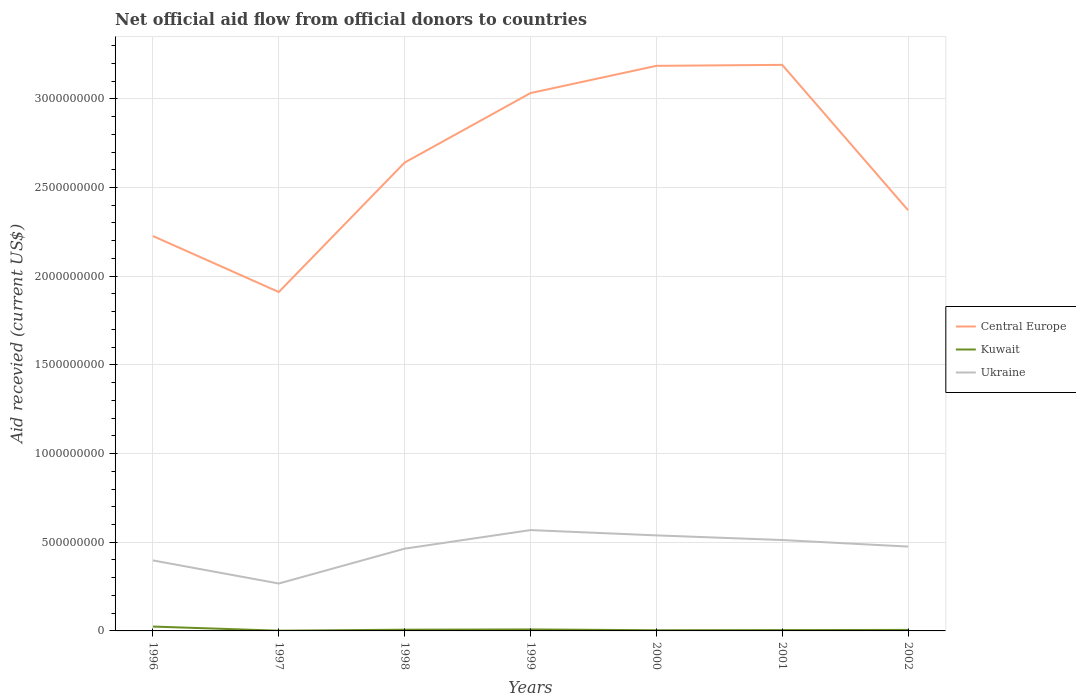How many different coloured lines are there?
Offer a terse response. 3. Does the line corresponding to Ukraine intersect with the line corresponding to Central Europe?
Keep it short and to the point. No. Is the number of lines equal to the number of legend labels?
Give a very brief answer. Yes. Across all years, what is the maximum total aid received in Kuwait?
Give a very brief answer. 1.28e+06. In which year was the total aid received in Central Europe maximum?
Your answer should be compact. 1997. What is the total total aid received in Kuwait in the graph?
Your answer should be compact. 1.63e+07. What is the difference between the highest and the second highest total aid received in Central Europe?
Give a very brief answer. 1.28e+09. What is the difference between the highest and the lowest total aid received in Ukraine?
Offer a very short reply. 5. Is the total aid received in Central Europe strictly greater than the total aid received in Ukraine over the years?
Offer a very short reply. No. How many lines are there?
Offer a terse response. 3. What is the difference between two consecutive major ticks on the Y-axis?
Offer a terse response. 5.00e+08. Are the values on the major ticks of Y-axis written in scientific E-notation?
Make the answer very short. No. Does the graph contain any zero values?
Ensure brevity in your answer.  No. Where does the legend appear in the graph?
Make the answer very short. Center right. How many legend labels are there?
Make the answer very short. 3. What is the title of the graph?
Your response must be concise. Net official aid flow from official donors to countries. Does "Montenegro" appear as one of the legend labels in the graph?
Your answer should be compact. No. What is the label or title of the Y-axis?
Keep it short and to the point. Aid recevied (current US$). What is the Aid recevied (current US$) in Central Europe in 1996?
Offer a terse response. 2.23e+09. What is the Aid recevied (current US$) of Kuwait in 1996?
Offer a very short reply. 2.46e+07. What is the Aid recevied (current US$) of Ukraine in 1996?
Offer a terse response. 3.98e+08. What is the Aid recevied (current US$) of Central Europe in 1997?
Provide a short and direct response. 1.91e+09. What is the Aid recevied (current US$) of Kuwait in 1997?
Make the answer very short. 1.28e+06. What is the Aid recevied (current US$) of Ukraine in 1997?
Keep it short and to the point. 2.67e+08. What is the Aid recevied (current US$) of Central Europe in 1998?
Keep it short and to the point. 2.64e+09. What is the Aid recevied (current US$) of Kuwait in 1998?
Keep it short and to the point. 6.99e+06. What is the Aid recevied (current US$) of Ukraine in 1998?
Make the answer very short. 4.64e+08. What is the Aid recevied (current US$) of Central Europe in 1999?
Give a very brief answer. 3.03e+09. What is the Aid recevied (current US$) of Kuwait in 1999?
Offer a terse response. 8.33e+06. What is the Aid recevied (current US$) of Ukraine in 1999?
Your response must be concise. 5.69e+08. What is the Aid recevied (current US$) of Central Europe in 2000?
Your response must be concise. 3.19e+09. What is the Aid recevied (current US$) in Kuwait in 2000?
Your answer should be compact. 3.89e+06. What is the Aid recevied (current US$) of Ukraine in 2000?
Your answer should be very brief. 5.39e+08. What is the Aid recevied (current US$) of Central Europe in 2001?
Your answer should be very brief. 3.19e+09. What is the Aid recevied (current US$) in Kuwait in 2001?
Provide a succinct answer. 4.69e+06. What is the Aid recevied (current US$) in Ukraine in 2001?
Make the answer very short. 5.12e+08. What is the Aid recevied (current US$) of Central Europe in 2002?
Provide a short and direct response. 2.37e+09. What is the Aid recevied (current US$) of Kuwait in 2002?
Provide a short and direct response. 5.71e+06. What is the Aid recevied (current US$) in Ukraine in 2002?
Provide a succinct answer. 4.76e+08. Across all years, what is the maximum Aid recevied (current US$) in Central Europe?
Keep it short and to the point. 3.19e+09. Across all years, what is the maximum Aid recevied (current US$) in Kuwait?
Your response must be concise. 2.46e+07. Across all years, what is the maximum Aid recevied (current US$) of Ukraine?
Provide a short and direct response. 5.69e+08. Across all years, what is the minimum Aid recevied (current US$) of Central Europe?
Make the answer very short. 1.91e+09. Across all years, what is the minimum Aid recevied (current US$) in Kuwait?
Provide a short and direct response. 1.28e+06. Across all years, what is the minimum Aid recevied (current US$) in Ukraine?
Ensure brevity in your answer.  2.67e+08. What is the total Aid recevied (current US$) of Central Europe in the graph?
Your response must be concise. 1.86e+1. What is the total Aid recevied (current US$) in Kuwait in the graph?
Provide a succinct answer. 5.55e+07. What is the total Aid recevied (current US$) of Ukraine in the graph?
Your answer should be compact. 3.22e+09. What is the difference between the Aid recevied (current US$) of Central Europe in 1996 and that in 1997?
Your answer should be very brief. 3.16e+08. What is the difference between the Aid recevied (current US$) of Kuwait in 1996 and that in 1997?
Make the answer very short. 2.33e+07. What is the difference between the Aid recevied (current US$) in Ukraine in 1996 and that in 1997?
Your response must be concise. 1.30e+08. What is the difference between the Aid recevied (current US$) in Central Europe in 1996 and that in 1998?
Offer a terse response. -4.14e+08. What is the difference between the Aid recevied (current US$) of Kuwait in 1996 and that in 1998?
Ensure brevity in your answer.  1.76e+07. What is the difference between the Aid recevied (current US$) in Ukraine in 1996 and that in 1998?
Make the answer very short. -6.61e+07. What is the difference between the Aid recevied (current US$) in Central Europe in 1996 and that in 1999?
Your response must be concise. -8.06e+08. What is the difference between the Aid recevied (current US$) of Kuwait in 1996 and that in 1999?
Your answer should be very brief. 1.63e+07. What is the difference between the Aid recevied (current US$) of Ukraine in 1996 and that in 1999?
Your answer should be compact. -1.71e+08. What is the difference between the Aid recevied (current US$) in Central Europe in 1996 and that in 2000?
Ensure brevity in your answer.  -9.60e+08. What is the difference between the Aid recevied (current US$) of Kuwait in 1996 and that in 2000?
Give a very brief answer. 2.07e+07. What is the difference between the Aid recevied (current US$) in Ukraine in 1996 and that in 2000?
Give a very brief answer. -1.41e+08. What is the difference between the Aid recevied (current US$) of Central Europe in 1996 and that in 2001?
Your answer should be compact. -9.65e+08. What is the difference between the Aid recevied (current US$) of Kuwait in 1996 and that in 2001?
Provide a short and direct response. 1.99e+07. What is the difference between the Aid recevied (current US$) of Ukraine in 1996 and that in 2001?
Provide a succinct answer. -1.15e+08. What is the difference between the Aid recevied (current US$) of Central Europe in 1996 and that in 2002?
Provide a succinct answer. -1.46e+08. What is the difference between the Aid recevied (current US$) in Kuwait in 1996 and that in 2002?
Give a very brief answer. 1.89e+07. What is the difference between the Aid recevied (current US$) in Ukraine in 1996 and that in 2002?
Offer a terse response. -7.79e+07. What is the difference between the Aid recevied (current US$) in Central Europe in 1997 and that in 1998?
Your response must be concise. -7.30e+08. What is the difference between the Aid recevied (current US$) in Kuwait in 1997 and that in 1998?
Provide a short and direct response. -5.71e+06. What is the difference between the Aid recevied (current US$) of Ukraine in 1997 and that in 1998?
Your response must be concise. -1.96e+08. What is the difference between the Aid recevied (current US$) in Central Europe in 1997 and that in 1999?
Offer a very short reply. -1.12e+09. What is the difference between the Aid recevied (current US$) of Kuwait in 1997 and that in 1999?
Provide a short and direct response. -7.05e+06. What is the difference between the Aid recevied (current US$) in Ukraine in 1997 and that in 1999?
Give a very brief answer. -3.01e+08. What is the difference between the Aid recevied (current US$) of Central Europe in 1997 and that in 2000?
Make the answer very short. -1.28e+09. What is the difference between the Aid recevied (current US$) in Kuwait in 1997 and that in 2000?
Ensure brevity in your answer.  -2.61e+06. What is the difference between the Aid recevied (current US$) of Ukraine in 1997 and that in 2000?
Keep it short and to the point. -2.71e+08. What is the difference between the Aid recevied (current US$) of Central Europe in 1997 and that in 2001?
Keep it short and to the point. -1.28e+09. What is the difference between the Aid recevied (current US$) of Kuwait in 1997 and that in 2001?
Your answer should be very brief. -3.41e+06. What is the difference between the Aid recevied (current US$) in Ukraine in 1997 and that in 2001?
Your answer should be very brief. -2.45e+08. What is the difference between the Aid recevied (current US$) in Central Europe in 1997 and that in 2002?
Ensure brevity in your answer.  -4.61e+08. What is the difference between the Aid recevied (current US$) in Kuwait in 1997 and that in 2002?
Provide a short and direct response. -4.43e+06. What is the difference between the Aid recevied (current US$) of Ukraine in 1997 and that in 2002?
Make the answer very short. -2.08e+08. What is the difference between the Aid recevied (current US$) of Central Europe in 1998 and that in 1999?
Provide a succinct answer. -3.92e+08. What is the difference between the Aid recevied (current US$) in Kuwait in 1998 and that in 1999?
Your answer should be compact. -1.34e+06. What is the difference between the Aid recevied (current US$) in Ukraine in 1998 and that in 1999?
Your response must be concise. -1.05e+08. What is the difference between the Aid recevied (current US$) in Central Europe in 1998 and that in 2000?
Give a very brief answer. -5.45e+08. What is the difference between the Aid recevied (current US$) in Kuwait in 1998 and that in 2000?
Keep it short and to the point. 3.10e+06. What is the difference between the Aid recevied (current US$) of Ukraine in 1998 and that in 2000?
Provide a short and direct response. -7.50e+07. What is the difference between the Aid recevied (current US$) of Central Europe in 1998 and that in 2001?
Ensure brevity in your answer.  -5.51e+08. What is the difference between the Aid recevied (current US$) in Kuwait in 1998 and that in 2001?
Offer a very short reply. 2.30e+06. What is the difference between the Aid recevied (current US$) of Ukraine in 1998 and that in 2001?
Offer a very short reply. -4.87e+07. What is the difference between the Aid recevied (current US$) of Central Europe in 1998 and that in 2002?
Your answer should be compact. 2.68e+08. What is the difference between the Aid recevied (current US$) in Kuwait in 1998 and that in 2002?
Provide a short and direct response. 1.28e+06. What is the difference between the Aid recevied (current US$) of Ukraine in 1998 and that in 2002?
Keep it short and to the point. -1.18e+07. What is the difference between the Aid recevied (current US$) in Central Europe in 1999 and that in 2000?
Provide a succinct answer. -1.54e+08. What is the difference between the Aid recevied (current US$) of Kuwait in 1999 and that in 2000?
Offer a terse response. 4.44e+06. What is the difference between the Aid recevied (current US$) in Ukraine in 1999 and that in 2000?
Make the answer very short. 2.98e+07. What is the difference between the Aid recevied (current US$) in Central Europe in 1999 and that in 2001?
Offer a terse response. -1.59e+08. What is the difference between the Aid recevied (current US$) in Kuwait in 1999 and that in 2001?
Your response must be concise. 3.64e+06. What is the difference between the Aid recevied (current US$) of Ukraine in 1999 and that in 2001?
Give a very brief answer. 5.61e+07. What is the difference between the Aid recevied (current US$) in Central Europe in 1999 and that in 2002?
Offer a terse response. 6.60e+08. What is the difference between the Aid recevied (current US$) of Kuwait in 1999 and that in 2002?
Your response must be concise. 2.62e+06. What is the difference between the Aid recevied (current US$) of Ukraine in 1999 and that in 2002?
Offer a terse response. 9.30e+07. What is the difference between the Aid recevied (current US$) in Central Europe in 2000 and that in 2001?
Your answer should be very brief. -5.47e+06. What is the difference between the Aid recevied (current US$) of Kuwait in 2000 and that in 2001?
Offer a terse response. -8.00e+05. What is the difference between the Aid recevied (current US$) of Ukraine in 2000 and that in 2001?
Ensure brevity in your answer.  2.62e+07. What is the difference between the Aid recevied (current US$) of Central Europe in 2000 and that in 2002?
Provide a succinct answer. 8.14e+08. What is the difference between the Aid recevied (current US$) of Kuwait in 2000 and that in 2002?
Provide a short and direct response. -1.82e+06. What is the difference between the Aid recevied (current US$) in Ukraine in 2000 and that in 2002?
Offer a terse response. 6.32e+07. What is the difference between the Aid recevied (current US$) in Central Europe in 2001 and that in 2002?
Keep it short and to the point. 8.19e+08. What is the difference between the Aid recevied (current US$) in Kuwait in 2001 and that in 2002?
Offer a very short reply. -1.02e+06. What is the difference between the Aid recevied (current US$) in Ukraine in 2001 and that in 2002?
Your answer should be very brief. 3.69e+07. What is the difference between the Aid recevied (current US$) in Central Europe in 1996 and the Aid recevied (current US$) in Kuwait in 1997?
Your response must be concise. 2.23e+09. What is the difference between the Aid recevied (current US$) in Central Europe in 1996 and the Aid recevied (current US$) in Ukraine in 1997?
Your answer should be very brief. 1.96e+09. What is the difference between the Aid recevied (current US$) in Kuwait in 1996 and the Aid recevied (current US$) in Ukraine in 1997?
Your answer should be very brief. -2.43e+08. What is the difference between the Aid recevied (current US$) of Central Europe in 1996 and the Aid recevied (current US$) of Kuwait in 1998?
Offer a very short reply. 2.22e+09. What is the difference between the Aid recevied (current US$) of Central Europe in 1996 and the Aid recevied (current US$) of Ukraine in 1998?
Your answer should be very brief. 1.76e+09. What is the difference between the Aid recevied (current US$) of Kuwait in 1996 and the Aid recevied (current US$) of Ukraine in 1998?
Give a very brief answer. -4.39e+08. What is the difference between the Aid recevied (current US$) of Central Europe in 1996 and the Aid recevied (current US$) of Kuwait in 1999?
Your answer should be very brief. 2.22e+09. What is the difference between the Aid recevied (current US$) in Central Europe in 1996 and the Aid recevied (current US$) in Ukraine in 1999?
Provide a short and direct response. 1.66e+09. What is the difference between the Aid recevied (current US$) of Kuwait in 1996 and the Aid recevied (current US$) of Ukraine in 1999?
Provide a short and direct response. -5.44e+08. What is the difference between the Aid recevied (current US$) of Central Europe in 1996 and the Aid recevied (current US$) of Kuwait in 2000?
Keep it short and to the point. 2.22e+09. What is the difference between the Aid recevied (current US$) in Central Europe in 1996 and the Aid recevied (current US$) in Ukraine in 2000?
Provide a short and direct response. 1.69e+09. What is the difference between the Aid recevied (current US$) in Kuwait in 1996 and the Aid recevied (current US$) in Ukraine in 2000?
Your answer should be very brief. -5.14e+08. What is the difference between the Aid recevied (current US$) in Central Europe in 1996 and the Aid recevied (current US$) in Kuwait in 2001?
Your answer should be compact. 2.22e+09. What is the difference between the Aid recevied (current US$) in Central Europe in 1996 and the Aid recevied (current US$) in Ukraine in 2001?
Your response must be concise. 1.71e+09. What is the difference between the Aid recevied (current US$) in Kuwait in 1996 and the Aid recevied (current US$) in Ukraine in 2001?
Keep it short and to the point. -4.88e+08. What is the difference between the Aid recevied (current US$) of Central Europe in 1996 and the Aid recevied (current US$) of Kuwait in 2002?
Ensure brevity in your answer.  2.22e+09. What is the difference between the Aid recevied (current US$) of Central Europe in 1996 and the Aid recevied (current US$) of Ukraine in 2002?
Ensure brevity in your answer.  1.75e+09. What is the difference between the Aid recevied (current US$) in Kuwait in 1996 and the Aid recevied (current US$) in Ukraine in 2002?
Your answer should be very brief. -4.51e+08. What is the difference between the Aid recevied (current US$) of Central Europe in 1997 and the Aid recevied (current US$) of Kuwait in 1998?
Give a very brief answer. 1.90e+09. What is the difference between the Aid recevied (current US$) of Central Europe in 1997 and the Aid recevied (current US$) of Ukraine in 1998?
Ensure brevity in your answer.  1.45e+09. What is the difference between the Aid recevied (current US$) of Kuwait in 1997 and the Aid recevied (current US$) of Ukraine in 1998?
Keep it short and to the point. -4.62e+08. What is the difference between the Aid recevied (current US$) of Central Europe in 1997 and the Aid recevied (current US$) of Kuwait in 1999?
Your answer should be compact. 1.90e+09. What is the difference between the Aid recevied (current US$) of Central Europe in 1997 and the Aid recevied (current US$) of Ukraine in 1999?
Provide a short and direct response. 1.34e+09. What is the difference between the Aid recevied (current US$) in Kuwait in 1997 and the Aid recevied (current US$) in Ukraine in 1999?
Provide a succinct answer. -5.67e+08. What is the difference between the Aid recevied (current US$) in Central Europe in 1997 and the Aid recevied (current US$) in Kuwait in 2000?
Offer a terse response. 1.91e+09. What is the difference between the Aid recevied (current US$) of Central Europe in 1997 and the Aid recevied (current US$) of Ukraine in 2000?
Keep it short and to the point. 1.37e+09. What is the difference between the Aid recevied (current US$) of Kuwait in 1997 and the Aid recevied (current US$) of Ukraine in 2000?
Your answer should be very brief. -5.37e+08. What is the difference between the Aid recevied (current US$) in Central Europe in 1997 and the Aid recevied (current US$) in Kuwait in 2001?
Your answer should be very brief. 1.91e+09. What is the difference between the Aid recevied (current US$) of Central Europe in 1997 and the Aid recevied (current US$) of Ukraine in 2001?
Give a very brief answer. 1.40e+09. What is the difference between the Aid recevied (current US$) of Kuwait in 1997 and the Aid recevied (current US$) of Ukraine in 2001?
Provide a succinct answer. -5.11e+08. What is the difference between the Aid recevied (current US$) in Central Europe in 1997 and the Aid recevied (current US$) in Kuwait in 2002?
Offer a terse response. 1.91e+09. What is the difference between the Aid recevied (current US$) of Central Europe in 1997 and the Aid recevied (current US$) of Ukraine in 2002?
Keep it short and to the point. 1.44e+09. What is the difference between the Aid recevied (current US$) in Kuwait in 1997 and the Aid recevied (current US$) in Ukraine in 2002?
Your answer should be very brief. -4.74e+08. What is the difference between the Aid recevied (current US$) in Central Europe in 1998 and the Aid recevied (current US$) in Kuwait in 1999?
Provide a succinct answer. 2.63e+09. What is the difference between the Aid recevied (current US$) in Central Europe in 1998 and the Aid recevied (current US$) in Ukraine in 1999?
Make the answer very short. 2.07e+09. What is the difference between the Aid recevied (current US$) of Kuwait in 1998 and the Aid recevied (current US$) of Ukraine in 1999?
Ensure brevity in your answer.  -5.62e+08. What is the difference between the Aid recevied (current US$) in Central Europe in 1998 and the Aid recevied (current US$) in Kuwait in 2000?
Offer a very short reply. 2.64e+09. What is the difference between the Aid recevied (current US$) in Central Europe in 1998 and the Aid recevied (current US$) in Ukraine in 2000?
Provide a short and direct response. 2.10e+09. What is the difference between the Aid recevied (current US$) in Kuwait in 1998 and the Aid recevied (current US$) in Ukraine in 2000?
Make the answer very short. -5.32e+08. What is the difference between the Aid recevied (current US$) of Central Europe in 1998 and the Aid recevied (current US$) of Kuwait in 2001?
Offer a terse response. 2.64e+09. What is the difference between the Aid recevied (current US$) of Central Europe in 1998 and the Aid recevied (current US$) of Ukraine in 2001?
Give a very brief answer. 2.13e+09. What is the difference between the Aid recevied (current US$) in Kuwait in 1998 and the Aid recevied (current US$) in Ukraine in 2001?
Offer a very short reply. -5.05e+08. What is the difference between the Aid recevied (current US$) of Central Europe in 1998 and the Aid recevied (current US$) of Kuwait in 2002?
Make the answer very short. 2.63e+09. What is the difference between the Aid recevied (current US$) in Central Europe in 1998 and the Aid recevied (current US$) in Ukraine in 2002?
Offer a terse response. 2.17e+09. What is the difference between the Aid recevied (current US$) in Kuwait in 1998 and the Aid recevied (current US$) in Ukraine in 2002?
Offer a very short reply. -4.69e+08. What is the difference between the Aid recevied (current US$) of Central Europe in 1999 and the Aid recevied (current US$) of Kuwait in 2000?
Provide a succinct answer. 3.03e+09. What is the difference between the Aid recevied (current US$) of Central Europe in 1999 and the Aid recevied (current US$) of Ukraine in 2000?
Your answer should be compact. 2.49e+09. What is the difference between the Aid recevied (current US$) of Kuwait in 1999 and the Aid recevied (current US$) of Ukraine in 2000?
Your answer should be compact. -5.30e+08. What is the difference between the Aid recevied (current US$) of Central Europe in 1999 and the Aid recevied (current US$) of Kuwait in 2001?
Make the answer very short. 3.03e+09. What is the difference between the Aid recevied (current US$) of Central Europe in 1999 and the Aid recevied (current US$) of Ukraine in 2001?
Your response must be concise. 2.52e+09. What is the difference between the Aid recevied (current US$) in Kuwait in 1999 and the Aid recevied (current US$) in Ukraine in 2001?
Provide a succinct answer. -5.04e+08. What is the difference between the Aid recevied (current US$) of Central Europe in 1999 and the Aid recevied (current US$) of Kuwait in 2002?
Give a very brief answer. 3.03e+09. What is the difference between the Aid recevied (current US$) in Central Europe in 1999 and the Aid recevied (current US$) in Ukraine in 2002?
Your response must be concise. 2.56e+09. What is the difference between the Aid recevied (current US$) in Kuwait in 1999 and the Aid recevied (current US$) in Ukraine in 2002?
Give a very brief answer. -4.67e+08. What is the difference between the Aid recevied (current US$) in Central Europe in 2000 and the Aid recevied (current US$) in Kuwait in 2001?
Keep it short and to the point. 3.18e+09. What is the difference between the Aid recevied (current US$) in Central Europe in 2000 and the Aid recevied (current US$) in Ukraine in 2001?
Provide a succinct answer. 2.67e+09. What is the difference between the Aid recevied (current US$) of Kuwait in 2000 and the Aid recevied (current US$) of Ukraine in 2001?
Your response must be concise. -5.09e+08. What is the difference between the Aid recevied (current US$) of Central Europe in 2000 and the Aid recevied (current US$) of Kuwait in 2002?
Your answer should be very brief. 3.18e+09. What is the difference between the Aid recevied (current US$) of Central Europe in 2000 and the Aid recevied (current US$) of Ukraine in 2002?
Make the answer very short. 2.71e+09. What is the difference between the Aid recevied (current US$) of Kuwait in 2000 and the Aid recevied (current US$) of Ukraine in 2002?
Keep it short and to the point. -4.72e+08. What is the difference between the Aid recevied (current US$) in Central Europe in 2001 and the Aid recevied (current US$) in Kuwait in 2002?
Offer a very short reply. 3.19e+09. What is the difference between the Aid recevied (current US$) of Central Europe in 2001 and the Aid recevied (current US$) of Ukraine in 2002?
Offer a terse response. 2.72e+09. What is the difference between the Aid recevied (current US$) in Kuwait in 2001 and the Aid recevied (current US$) in Ukraine in 2002?
Offer a very short reply. -4.71e+08. What is the average Aid recevied (current US$) of Central Europe per year?
Ensure brevity in your answer.  2.65e+09. What is the average Aid recevied (current US$) in Kuwait per year?
Offer a terse response. 7.93e+06. What is the average Aid recevied (current US$) of Ukraine per year?
Offer a terse response. 4.61e+08. In the year 1996, what is the difference between the Aid recevied (current US$) in Central Europe and Aid recevied (current US$) in Kuwait?
Provide a short and direct response. 2.20e+09. In the year 1996, what is the difference between the Aid recevied (current US$) in Central Europe and Aid recevied (current US$) in Ukraine?
Your answer should be compact. 1.83e+09. In the year 1996, what is the difference between the Aid recevied (current US$) of Kuwait and Aid recevied (current US$) of Ukraine?
Your response must be concise. -3.73e+08. In the year 1997, what is the difference between the Aid recevied (current US$) of Central Europe and Aid recevied (current US$) of Kuwait?
Provide a short and direct response. 1.91e+09. In the year 1997, what is the difference between the Aid recevied (current US$) of Central Europe and Aid recevied (current US$) of Ukraine?
Your response must be concise. 1.64e+09. In the year 1997, what is the difference between the Aid recevied (current US$) of Kuwait and Aid recevied (current US$) of Ukraine?
Keep it short and to the point. -2.66e+08. In the year 1998, what is the difference between the Aid recevied (current US$) in Central Europe and Aid recevied (current US$) in Kuwait?
Provide a succinct answer. 2.63e+09. In the year 1998, what is the difference between the Aid recevied (current US$) of Central Europe and Aid recevied (current US$) of Ukraine?
Ensure brevity in your answer.  2.18e+09. In the year 1998, what is the difference between the Aid recevied (current US$) of Kuwait and Aid recevied (current US$) of Ukraine?
Offer a terse response. -4.57e+08. In the year 1999, what is the difference between the Aid recevied (current US$) of Central Europe and Aid recevied (current US$) of Kuwait?
Your answer should be compact. 3.02e+09. In the year 1999, what is the difference between the Aid recevied (current US$) of Central Europe and Aid recevied (current US$) of Ukraine?
Keep it short and to the point. 2.46e+09. In the year 1999, what is the difference between the Aid recevied (current US$) in Kuwait and Aid recevied (current US$) in Ukraine?
Offer a terse response. -5.60e+08. In the year 2000, what is the difference between the Aid recevied (current US$) in Central Europe and Aid recevied (current US$) in Kuwait?
Offer a terse response. 3.18e+09. In the year 2000, what is the difference between the Aid recevied (current US$) of Central Europe and Aid recevied (current US$) of Ukraine?
Offer a terse response. 2.65e+09. In the year 2000, what is the difference between the Aid recevied (current US$) in Kuwait and Aid recevied (current US$) in Ukraine?
Keep it short and to the point. -5.35e+08. In the year 2001, what is the difference between the Aid recevied (current US$) in Central Europe and Aid recevied (current US$) in Kuwait?
Ensure brevity in your answer.  3.19e+09. In the year 2001, what is the difference between the Aid recevied (current US$) in Central Europe and Aid recevied (current US$) in Ukraine?
Provide a succinct answer. 2.68e+09. In the year 2001, what is the difference between the Aid recevied (current US$) of Kuwait and Aid recevied (current US$) of Ukraine?
Ensure brevity in your answer.  -5.08e+08. In the year 2002, what is the difference between the Aid recevied (current US$) in Central Europe and Aid recevied (current US$) in Kuwait?
Keep it short and to the point. 2.37e+09. In the year 2002, what is the difference between the Aid recevied (current US$) of Central Europe and Aid recevied (current US$) of Ukraine?
Provide a succinct answer. 1.90e+09. In the year 2002, what is the difference between the Aid recevied (current US$) of Kuwait and Aid recevied (current US$) of Ukraine?
Your answer should be very brief. -4.70e+08. What is the ratio of the Aid recevied (current US$) in Central Europe in 1996 to that in 1997?
Give a very brief answer. 1.17. What is the ratio of the Aid recevied (current US$) of Kuwait in 1996 to that in 1997?
Provide a succinct answer. 19.22. What is the ratio of the Aid recevied (current US$) of Ukraine in 1996 to that in 1997?
Your answer should be compact. 1.49. What is the ratio of the Aid recevied (current US$) in Central Europe in 1996 to that in 1998?
Keep it short and to the point. 0.84. What is the ratio of the Aid recevied (current US$) of Kuwait in 1996 to that in 1998?
Offer a terse response. 3.52. What is the ratio of the Aid recevied (current US$) of Ukraine in 1996 to that in 1998?
Ensure brevity in your answer.  0.86. What is the ratio of the Aid recevied (current US$) in Central Europe in 1996 to that in 1999?
Ensure brevity in your answer.  0.73. What is the ratio of the Aid recevied (current US$) of Kuwait in 1996 to that in 1999?
Offer a terse response. 2.95. What is the ratio of the Aid recevied (current US$) in Ukraine in 1996 to that in 1999?
Provide a short and direct response. 0.7. What is the ratio of the Aid recevied (current US$) of Central Europe in 1996 to that in 2000?
Offer a very short reply. 0.7. What is the ratio of the Aid recevied (current US$) of Kuwait in 1996 to that in 2000?
Provide a succinct answer. 6.32. What is the ratio of the Aid recevied (current US$) in Ukraine in 1996 to that in 2000?
Your response must be concise. 0.74. What is the ratio of the Aid recevied (current US$) in Central Europe in 1996 to that in 2001?
Your answer should be very brief. 0.7. What is the ratio of the Aid recevied (current US$) of Kuwait in 1996 to that in 2001?
Your answer should be compact. 5.25. What is the ratio of the Aid recevied (current US$) in Ukraine in 1996 to that in 2001?
Ensure brevity in your answer.  0.78. What is the ratio of the Aid recevied (current US$) of Central Europe in 1996 to that in 2002?
Your answer should be very brief. 0.94. What is the ratio of the Aid recevied (current US$) of Kuwait in 1996 to that in 2002?
Provide a short and direct response. 4.31. What is the ratio of the Aid recevied (current US$) of Ukraine in 1996 to that in 2002?
Keep it short and to the point. 0.84. What is the ratio of the Aid recevied (current US$) of Central Europe in 1997 to that in 1998?
Offer a terse response. 0.72. What is the ratio of the Aid recevied (current US$) in Kuwait in 1997 to that in 1998?
Offer a terse response. 0.18. What is the ratio of the Aid recevied (current US$) of Ukraine in 1997 to that in 1998?
Provide a succinct answer. 0.58. What is the ratio of the Aid recevied (current US$) of Central Europe in 1997 to that in 1999?
Provide a short and direct response. 0.63. What is the ratio of the Aid recevied (current US$) in Kuwait in 1997 to that in 1999?
Your response must be concise. 0.15. What is the ratio of the Aid recevied (current US$) in Ukraine in 1997 to that in 1999?
Your response must be concise. 0.47. What is the ratio of the Aid recevied (current US$) of Central Europe in 1997 to that in 2000?
Your response must be concise. 0.6. What is the ratio of the Aid recevied (current US$) in Kuwait in 1997 to that in 2000?
Your answer should be compact. 0.33. What is the ratio of the Aid recevied (current US$) in Ukraine in 1997 to that in 2000?
Provide a short and direct response. 0.5. What is the ratio of the Aid recevied (current US$) of Central Europe in 1997 to that in 2001?
Ensure brevity in your answer.  0.6. What is the ratio of the Aid recevied (current US$) in Kuwait in 1997 to that in 2001?
Your answer should be very brief. 0.27. What is the ratio of the Aid recevied (current US$) of Ukraine in 1997 to that in 2001?
Offer a terse response. 0.52. What is the ratio of the Aid recevied (current US$) of Central Europe in 1997 to that in 2002?
Your answer should be compact. 0.81. What is the ratio of the Aid recevied (current US$) in Kuwait in 1997 to that in 2002?
Ensure brevity in your answer.  0.22. What is the ratio of the Aid recevied (current US$) of Ukraine in 1997 to that in 2002?
Your answer should be compact. 0.56. What is the ratio of the Aid recevied (current US$) of Central Europe in 1998 to that in 1999?
Offer a terse response. 0.87. What is the ratio of the Aid recevied (current US$) of Kuwait in 1998 to that in 1999?
Ensure brevity in your answer.  0.84. What is the ratio of the Aid recevied (current US$) of Ukraine in 1998 to that in 1999?
Your answer should be compact. 0.82. What is the ratio of the Aid recevied (current US$) of Central Europe in 1998 to that in 2000?
Ensure brevity in your answer.  0.83. What is the ratio of the Aid recevied (current US$) in Kuwait in 1998 to that in 2000?
Make the answer very short. 1.8. What is the ratio of the Aid recevied (current US$) of Ukraine in 1998 to that in 2000?
Give a very brief answer. 0.86. What is the ratio of the Aid recevied (current US$) of Central Europe in 1998 to that in 2001?
Give a very brief answer. 0.83. What is the ratio of the Aid recevied (current US$) of Kuwait in 1998 to that in 2001?
Your answer should be compact. 1.49. What is the ratio of the Aid recevied (current US$) in Ukraine in 1998 to that in 2001?
Make the answer very short. 0.91. What is the ratio of the Aid recevied (current US$) in Central Europe in 1998 to that in 2002?
Your answer should be very brief. 1.11. What is the ratio of the Aid recevied (current US$) in Kuwait in 1998 to that in 2002?
Make the answer very short. 1.22. What is the ratio of the Aid recevied (current US$) in Ukraine in 1998 to that in 2002?
Offer a terse response. 0.98. What is the ratio of the Aid recevied (current US$) in Central Europe in 1999 to that in 2000?
Make the answer very short. 0.95. What is the ratio of the Aid recevied (current US$) of Kuwait in 1999 to that in 2000?
Keep it short and to the point. 2.14. What is the ratio of the Aid recevied (current US$) of Ukraine in 1999 to that in 2000?
Make the answer very short. 1.06. What is the ratio of the Aid recevied (current US$) in Central Europe in 1999 to that in 2001?
Provide a succinct answer. 0.95. What is the ratio of the Aid recevied (current US$) of Kuwait in 1999 to that in 2001?
Provide a succinct answer. 1.78. What is the ratio of the Aid recevied (current US$) of Ukraine in 1999 to that in 2001?
Keep it short and to the point. 1.11. What is the ratio of the Aid recevied (current US$) in Central Europe in 1999 to that in 2002?
Provide a succinct answer. 1.28. What is the ratio of the Aid recevied (current US$) of Kuwait in 1999 to that in 2002?
Keep it short and to the point. 1.46. What is the ratio of the Aid recevied (current US$) in Ukraine in 1999 to that in 2002?
Give a very brief answer. 1.2. What is the ratio of the Aid recevied (current US$) of Kuwait in 2000 to that in 2001?
Your answer should be very brief. 0.83. What is the ratio of the Aid recevied (current US$) in Ukraine in 2000 to that in 2001?
Give a very brief answer. 1.05. What is the ratio of the Aid recevied (current US$) in Central Europe in 2000 to that in 2002?
Provide a short and direct response. 1.34. What is the ratio of the Aid recevied (current US$) in Kuwait in 2000 to that in 2002?
Your response must be concise. 0.68. What is the ratio of the Aid recevied (current US$) of Ukraine in 2000 to that in 2002?
Offer a very short reply. 1.13. What is the ratio of the Aid recevied (current US$) of Central Europe in 2001 to that in 2002?
Your answer should be compact. 1.35. What is the ratio of the Aid recevied (current US$) of Kuwait in 2001 to that in 2002?
Ensure brevity in your answer.  0.82. What is the ratio of the Aid recevied (current US$) of Ukraine in 2001 to that in 2002?
Give a very brief answer. 1.08. What is the difference between the highest and the second highest Aid recevied (current US$) in Central Europe?
Your response must be concise. 5.47e+06. What is the difference between the highest and the second highest Aid recevied (current US$) in Kuwait?
Give a very brief answer. 1.63e+07. What is the difference between the highest and the second highest Aid recevied (current US$) in Ukraine?
Offer a very short reply. 2.98e+07. What is the difference between the highest and the lowest Aid recevied (current US$) in Central Europe?
Give a very brief answer. 1.28e+09. What is the difference between the highest and the lowest Aid recevied (current US$) of Kuwait?
Ensure brevity in your answer.  2.33e+07. What is the difference between the highest and the lowest Aid recevied (current US$) of Ukraine?
Offer a terse response. 3.01e+08. 